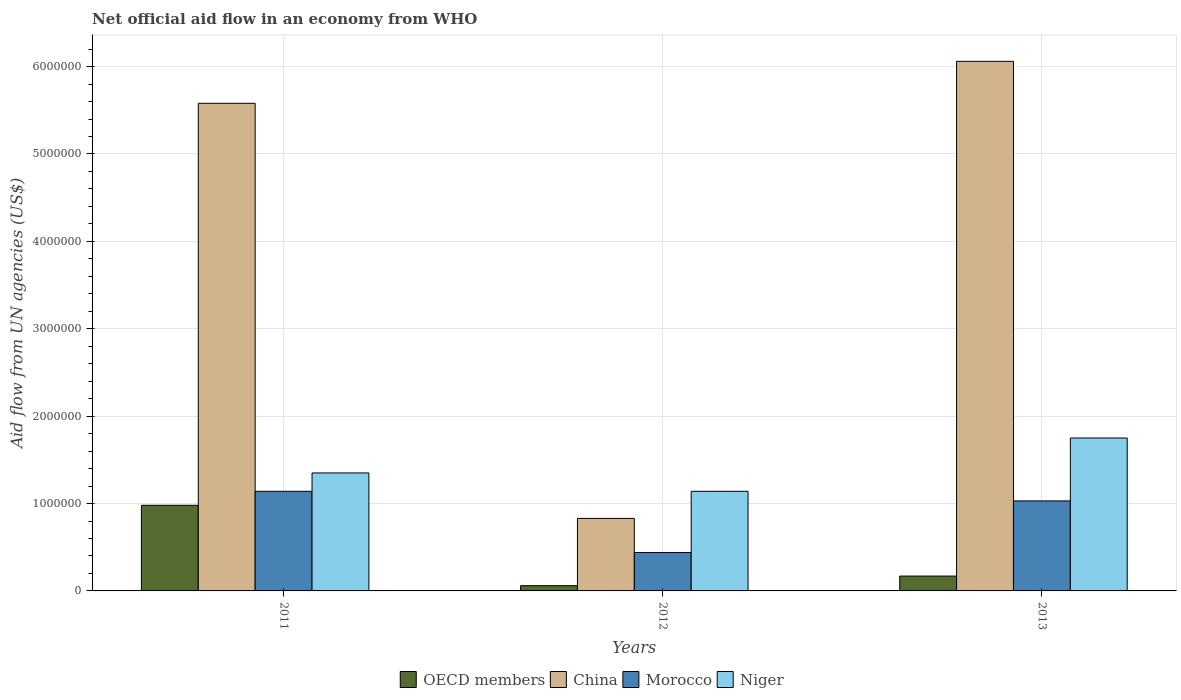How many different coloured bars are there?
Your response must be concise. 4. Are the number of bars per tick equal to the number of legend labels?
Give a very brief answer. Yes. How many bars are there on the 3rd tick from the right?
Give a very brief answer. 4. In how many cases, is the number of bars for a given year not equal to the number of legend labels?
Provide a short and direct response. 0. What is the net official aid flow in Niger in 2013?
Provide a succinct answer. 1.75e+06. Across all years, what is the maximum net official aid flow in Morocco?
Offer a very short reply. 1.14e+06. Across all years, what is the minimum net official aid flow in China?
Offer a very short reply. 8.30e+05. In which year was the net official aid flow in Niger minimum?
Your response must be concise. 2012. What is the total net official aid flow in OECD members in the graph?
Your response must be concise. 1.21e+06. What is the difference between the net official aid flow in OECD members in 2012 and that in 2013?
Offer a terse response. -1.10e+05. What is the difference between the net official aid flow in OECD members in 2012 and the net official aid flow in Niger in 2013?
Your answer should be very brief. -1.69e+06. What is the average net official aid flow in China per year?
Offer a terse response. 4.16e+06. In the year 2012, what is the difference between the net official aid flow in OECD members and net official aid flow in Morocco?
Provide a succinct answer. -3.80e+05. What is the ratio of the net official aid flow in Niger in 2011 to that in 2012?
Ensure brevity in your answer.  1.18. Is the net official aid flow in China in 2011 less than that in 2013?
Make the answer very short. Yes. Is the difference between the net official aid flow in OECD members in 2011 and 2013 greater than the difference between the net official aid flow in Morocco in 2011 and 2013?
Give a very brief answer. Yes. What is the difference between the highest and the lowest net official aid flow in OECD members?
Your answer should be compact. 9.20e+05. What does the 4th bar from the left in 2013 represents?
Offer a very short reply. Niger. What does the 2nd bar from the right in 2013 represents?
Give a very brief answer. Morocco. What is the difference between two consecutive major ticks on the Y-axis?
Offer a terse response. 1.00e+06. Are the values on the major ticks of Y-axis written in scientific E-notation?
Your response must be concise. No. Does the graph contain any zero values?
Your answer should be compact. No. How many legend labels are there?
Your answer should be very brief. 4. How are the legend labels stacked?
Give a very brief answer. Horizontal. What is the title of the graph?
Make the answer very short. Net official aid flow in an economy from WHO. Does "Iraq" appear as one of the legend labels in the graph?
Give a very brief answer. No. What is the label or title of the X-axis?
Provide a succinct answer. Years. What is the label or title of the Y-axis?
Offer a terse response. Aid flow from UN agencies (US$). What is the Aid flow from UN agencies (US$) in OECD members in 2011?
Give a very brief answer. 9.80e+05. What is the Aid flow from UN agencies (US$) of China in 2011?
Give a very brief answer. 5.58e+06. What is the Aid flow from UN agencies (US$) of Morocco in 2011?
Provide a short and direct response. 1.14e+06. What is the Aid flow from UN agencies (US$) of Niger in 2011?
Provide a short and direct response. 1.35e+06. What is the Aid flow from UN agencies (US$) in China in 2012?
Provide a succinct answer. 8.30e+05. What is the Aid flow from UN agencies (US$) in Niger in 2012?
Ensure brevity in your answer.  1.14e+06. What is the Aid flow from UN agencies (US$) in OECD members in 2013?
Ensure brevity in your answer.  1.70e+05. What is the Aid flow from UN agencies (US$) in China in 2013?
Your answer should be compact. 6.06e+06. What is the Aid flow from UN agencies (US$) of Morocco in 2013?
Keep it short and to the point. 1.03e+06. What is the Aid flow from UN agencies (US$) in Niger in 2013?
Give a very brief answer. 1.75e+06. Across all years, what is the maximum Aid flow from UN agencies (US$) in OECD members?
Your answer should be compact. 9.80e+05. Across all years, what is the maximum Aid flow from UN agencies (US$) in China?
Ensure brevity in your answer.  6.06e+06. Across all years, what is the maximum Aid flow from UN agencies (US$) in Morocco?
Provide a succinct answer. 1.14e+06. Across all years, what is the maximum Aid flow from UN agencies (US$) in Niger?
Make the answer very short. 1.75e+06. Across all years, what is the minimum Aid flow from UN agencies (US$) of OECD members?
Provide a succinct answer. 6.00e+04. Across all years, what is the minimum Aid flow from UN agencies (US$) of China?
Ensure brevity in your answer.  8.30e+05. Across all years, what is the minimum Aid flow from UN agencies (US$) of Morocco?
Offer a terse response. 4.40e+05. Across all years, what is the minimum Aid flow from UN agencies (US$) of Niger?
Give a very brief answer. 1.14e+06. What is the total Aid flow from UN agencies (US$) in OECD members in the graph?
Provide a short and direct response. 1.21e+06. What is the total Aid flow from UN agencies (US$) in China in the graph?
Provide a succinct answer. 1.25e+07. What is the total Aid flow from UN agencies (US$) of Morocco in the graph?
Make the answer very short. 2.61e+06. What is the total Aid flow from UN agencies (US$) of Niger in the graph?
Provide a succinct answer. 4.24e+06. What is the difference between the Aid flow from UN agencies (US$) of OECD members in 2011 and that in 2012?
Your response must be concise. 9.20e+05. What is the difference between the Aid flow from UN agencies (US$) of China in 2011 and that in 2012?
Provide a short and direct response. 4.75e+06. What is the difference between the Aid flow from UN agencies (US$) of Morocco in 2011 and that in 2012?
Ensure brevity in your answer.  7.00e+05. What is the difference between the Aid flow from UN agencies (US$) of Niger in 2011 and that in 2012?
Make the answer very short. 2.10e+05. What is the difference between the Aid flow from UN agencies (US$) of OECD members in 2011 and that in 2013?
Ensure brevity in your answer.  8.10e+05. What is the difference between the Aid flow from UN agencies (US$) in China in 2011 and that in 2013?
Give a very brief answer. -4.80e+05. What is the difference between the Aid flow from UN agencies (US$) of Niger in 2011 and that in 2013?
Offer a very short reply. -4.00e+05. What is the difference between the Aid flow from UN agencies (US$) of China in 2012 and that in 2013?
Your response must be concise. -5.23e+06. What is the difference between the Aid flow from UN agencies (US$) in Morocco in 2012 and that in 2013?
Provide a succinct answer. -5.90e+05. What is the difference between the Aid flow from UN agencies (US$) in Niger in 2012 and that in 2013?
Ensure brevity in your answer.  -6.10e+05. What is the difference between the Aid flow from UN agencies (US$) of OECD members in 2011 and the Aid flow from UN agencies (US$) of Morocco in 2012?
Provide a succinct answer. 5.40e+05. What is the difference between the Aid flow from UN agencies (US$) in China in 2011 and the Aid flow from UN agencies (US$) in Morocco in 2012?
Offer a terse response. 5.14e+06. What is the difference between the Aid flow from UN agencies (US$) in China in 2011 and the Aid flow from UN agencies (US$) in Niger in 2012?
Ensure brevity in your answer.  4.44e+06. What is the difference between the Aid flow from UN agencies (US$) in OECD members in 2011 and the Aid flow from UN agencies (US$) in China in 2013?
Provide a succinct answer. -5.08e+06. What is the difference between the Aid flow from UN agencies (US$) in OECD members in 2011 and the Aid flow from UN agencies (US$) in Niger in 2013?
Make the answer very short. -7.70e+05. What is the difference between the Aid flow from UN agencies (US$) in China in 2011 and the Aid flow from UN agencies (US$) in Morocco in 2013?
Your answer should be very brief. 4.55e+06. What is the difference between the Aid flow from UN agencies (US$) in China in 2011 and the Aid flow from UN agencies (US$) in Niger in 2013?
Offer a terse response. 3.83e+06. What is the difference between the Aid flow from UN agencies (US$) of Morocco in 2011 and the Aid flow from UN agencies (US$) of Niger in 2013?
Keep it short and to the point. -6.10e+05. What is the difference between the Aid flow from UN agencies (US$) in OECD members in 2012 and the Aid flow from UN agencies (US$) in China in 2013?
Offer a very short reply. -6.00e+06. What is the difference between the Aid flow from UN agencies (US$) in OECD members in 2012 and the Aid flow from UN agencies (US$) in Morocco in 2013?
Your response must be concise. -9.70e+05. What is the difference between the Aid flow from UN agencies (US$) in OECD members in 2012 and the Aid flow from UN agencies (US$) in Niger in 2013?
Your response must be concise. -1.69e+06. What is the difference between the Aid flow from UN agencies (US$) of China in 2012 and the Aid flow from UN agencies (US$) of Niger in 2013?
Your answer should be very brief. -9.20e+05. What is the difference between the Aid flow from UN agencies (US$) in Morocco in 2012 and the Aid flow from UN agencies (US$) in Niger in 2013?
Give a very brief answer. -1.31e+06. What is the average Aid flow from UN agencies (US$) in OECD members per year?
Provide a short and direct response. 4.03e+05. What is the average Aid flow from UN agencies (US$) in China per year?
Offer a very short reply. 4.16e+06. What is the average Aid flow from UN agencies (US$) in Morocco per year?
Offer a terse response. 8.70e+05. What is the average Aid flow from UN agencies (US$) of Niger per year?
Keep it short and to the point. 1.41e+06. In the year 2011, what is the difference between the Aid flow from UN agencies (US$) of OECD members and Aid flow from UN agencies (US$) of China?
Provide a succinct answer. -4.60e+06. In the year 2011, what is the difference between the Aid flow from UN agencies (US$) in OECD members and Aid flow from UN agencies (US$) in Morocco?
Give a very brief answer. -1.60e+05. In the year 2011, what is the difference between the Aid flow from UN agencies (US$) in OECD members and Aid flow from UN agencies (US$) in Niger?
Make the answer very short. -3.70e+05. In the year 2011, what is the difference between the Aid flow from UN agencies (US$) of China and Aid flow from UN agencies (US$) of Morocco?
Ensure brevity in your answer.  4.44e+06. In the year 2011, what is the difference between the Aid flow from UN agencies (US$) in China and Aid flow from UN agencies (US$) in Niger?
Provide a succinct answer. 4.23e+06. In the year 2012, what is the difference between the Aid flow from UN agencies (US$) of OECD members and Aid flow from UN agencies (US$) of China?
Keep it short and to the point. -7.70e+05. In the year 2012, what is the difference between the Aid flow from UN agencies (US$) in OECD members and Aid flow from UN agencies (US$) in Morocco?
Your response must be concise. -3.80e+05. In the year 2012, what is the difference between the Aid flow from UN agencies (US$) in OECD members and Aid flow from UN agencies (US$) in Niger?
Your answer should be compact. -1.08e+06. In the year 2012, what is the difference between the Aid flow from UN agencies (US$) of China and Aid flow from UN agencies (US$) of Niger?
Provide a short and direct response. -3.10e+05. In the year 2012, what is the difference between the Aid flow from UN agencies (US$) of Morocco and Aid flow from UN agencies (US$) of Niger?
Your answer should be very brief. -7.00e+05. In the year 2013, what is the difference between the Aid flow from UN agencies (US$) of OECD members and Aid flow from UN agencies (US$) of China?
Provide a succinct answer. -5.89e+06. In the year 2013, what is the difference between the Aid flow from UN agencies (US$) of OECD members and Aid flow from UN agencies (US$) of Morocco?
Provide a succinct answer. -8.60e+05. In the year 2013, what is the difference between the Aid flow from UN agencies (US$) in OECD members and Aid flow from UN agencies (US$) in Niger?
Provide a succinct answer. -1.58e+06. In the year 2013, what is the difference between the Aid flow from UN agencies (US$) of China and Aid flow from UN agencies (US$) of Morocco?
Your answer should be compact. 5.03e+06. In the year 2013, what is the difference between the Aid flow from UN agencies (US$) of China and Aid flow from UN agencies (US$) of Niger?
Provide a short and direct response. 4.31e+06. In the year 2013, what is the difference between the Aid flow from UN agencies (US$) of Morocco and Aid flow from UN agencies (US$) of Niger?
Keep it short and to the point. -7.20e+05. What is the ratio of the Aid flow from UN agencies (US$) in OECD members in 2011 to that in 2012?
Your answer should be compact. 16.33. What is the ratio of the Aid flow from UN agencies (US$) of China in 2011 to that in 2012?
Offer a terse response. 6.72. What is the ratio of the Aid flow from UN agencies (US$) in Morocco in 2011 to that in 2012?
Ensure brevity in your answer.  2.59. What is the ratio of the Aid flow from UN agencies (US$) in Niger in 2011 to that in 2012?
Provide a short and direct response. 1.18. What is the ratio of the Aid flow from UN agencies (US$) of OECD members in 2011 to that in 2013?
Provide a succinct answer. 5.76. What is the ratio of the Aid flow from UN agencies (US$) in China in 2011 to that in 2013?
Offer a terse response. 0.92. What is the ratio of the Aid flow from UN agencies (US$) of Morocco in 2011 to that in 2013?
Offer a very short reply. 1.11. What is the ratio of the Aid flow from UN agencies (US$) in Niger in 2011 to that in 2013?
Offer a very short reply. 0.77. What is the ratio of the Aid flow from UN agencies (US$) of OECD members in 2012 to that in 2013?
Provide a short and direct response. 0.35. What is the ratio of the Aid flow from UN agencies (US$) in China in 2012 to that in 2013?
Make the answer very short. 0.14. What is the ratio of the Aid flow from UN agencies (US$) in Morocco in 2012 to that in 2013?
Your answer should be very brief. 0.43. What is the ratio of the Aid flow from UN agencies (US$) of Niger in 2012 to that in 2013?
Your answer should be compact. 0.65. What is the difference between the highest and the second highest Aid flow from UN agencies (US$) in OECD members?
Give a very brief answer. 8.10e+05. What is the difference between the highest and the second highest Aid flow from UN agencies (US$) of China?
Provide a short and direct response. 4.80e+05. What is the difference between the highest and the lowest Aid flow from UN agencies (US$) in OECD members?
Make the answer very short. 9.20e+05. What is the difference between the highest and the lowest Aid flow from UN agencies (US$) of China?
Provide a succinct answer. 5.23e+06. What is the difference between the highest and the lowest Aid flow from UN agencies (US$) of Morocco?
Your answer should be very brief. 7.00e+05. 